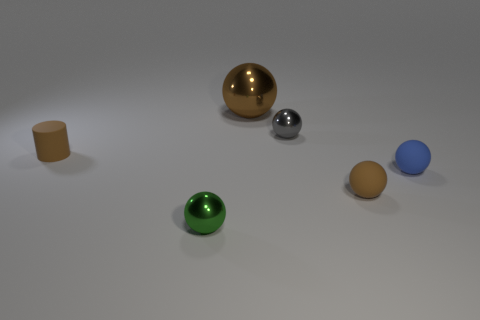Subtract all blue spheres. How many spheres are left? 4 Subtract all small brown rubber balls. How many balls are left? 4 Subtract 1 spheres. How many spheres are left? 4 Subtract all yellow spheres. Subtract all blue cubes. How many spheres are left? 5 Add 1 green metal spheres. How many objects exist? 7 Subtract all cylinders. How many objects are left? 5 Subtract all brown balls. Subtract all brown matte spheres. How many objects are left? 3 Add 5 big balls. How many big balls are left? 6 Add 1 small brown spheres. How many small brown spheres exist? 2 Subtract 1 green balls. How many objects are left? 5 